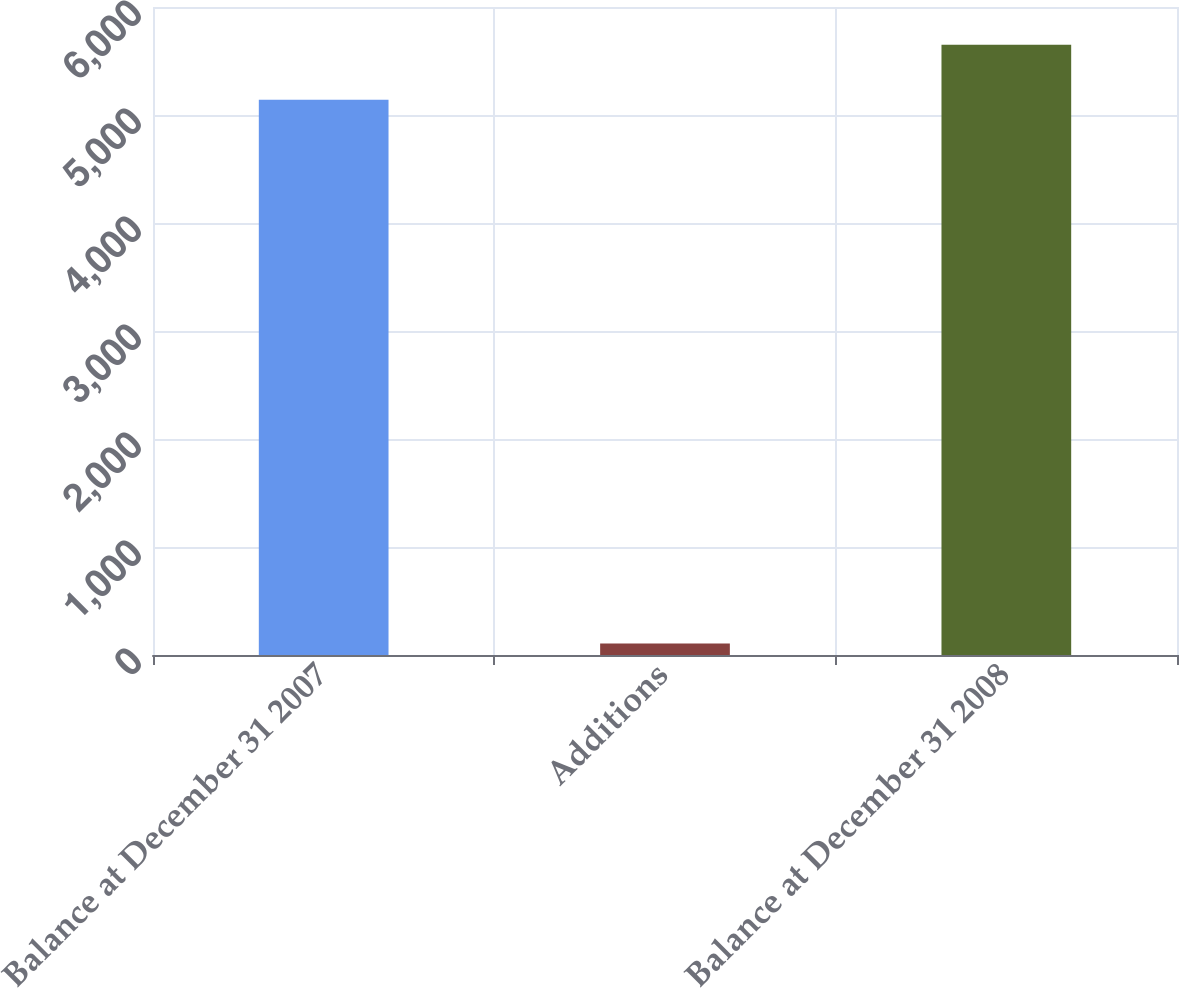Convert chart. <chart><loc_0><loc_0><loc_500><loc_500><bar_chart><fcel>Balance at December 31 2007<fcel>Additions<fcel>Balance at December 31 2008<nl><fcel>5142<fcel>107<fcel>5650.2<nl></chart> 